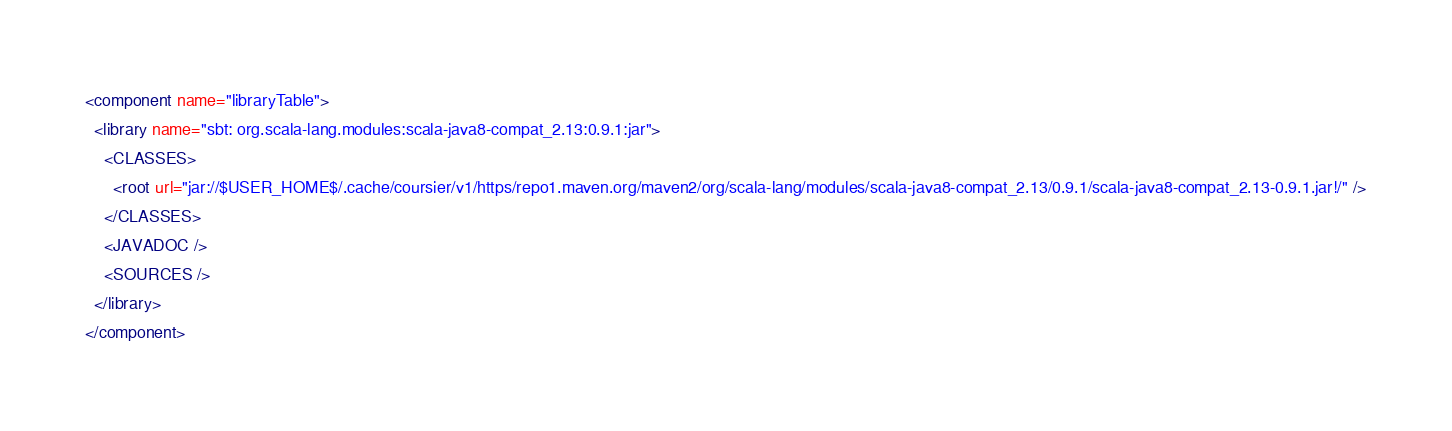<code> <loc_0><loc_0><loc_500><loc_500><_XML_><component name="libraryTable">
  <library name="sbt: org.scala-lang.modules:scala-java8-compat_2.13:0.9.1:jar">
    <CLASSES>
      <root url="jar://$USER_HOME$/.cache/coursier/v1/https/repo1.maven.org/maven2/org/scala-lang/modules/scala-java8-compat_2.13/0.9.1/scala-java8-compat_2.13-0.9.1.jar!/" />
    </CLASSES>
    <JAVADOC />
    <SOURCES />
  </library>
</component></code> 